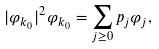Convert formula to latex. <formula><loc_0><loc_0><loc_500><loc_500>| \varphi _ { k _ { 0 } } | ^ { 2 } \varphi _ { k _ { 0 } } = \sum _ { j \geq 0 } p _ { j } \varphi _ { j } ,</formula> 